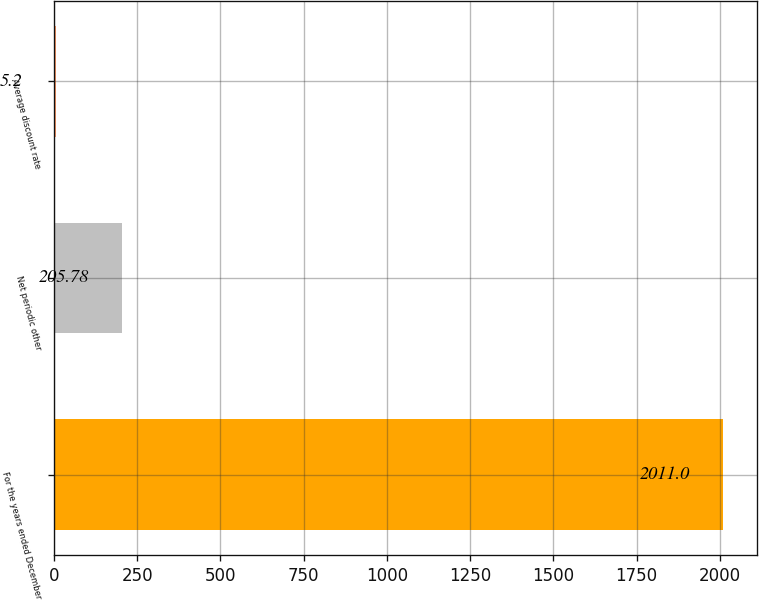<chart> <loc_0><loc_0><loc_500><loc_500><bar_chart><fcel>For the years ended December<fcel>Net periodic other<fcel>Average discount rate<nl><fcel>2011<fcel>205.78<fcel>5.2<nl></chart> 